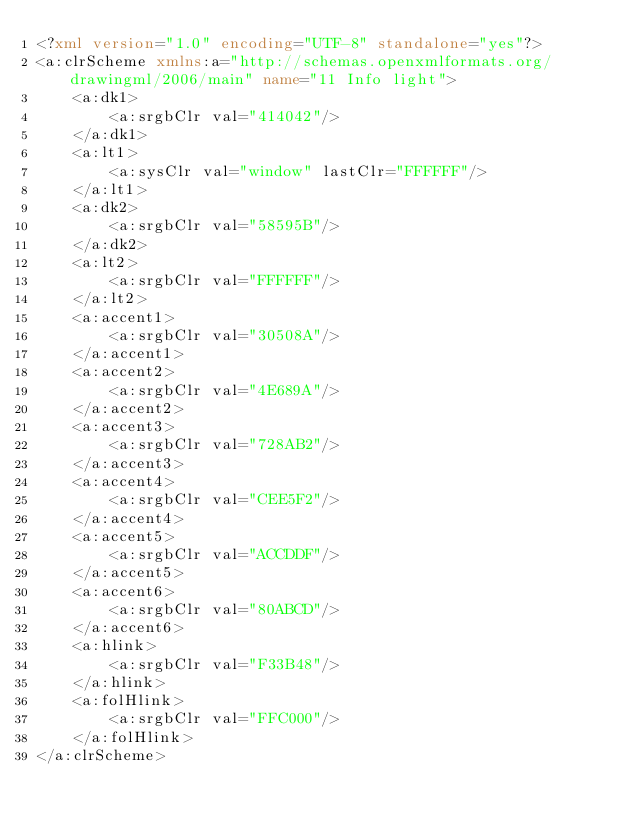<code> <loc_0><loc_0><loc_500><loc_500><_XML_><?xml version="1.0" encoding="UTF-8" standalone="yes"?>
<a:clrScheme xmlns:a="http://schemas.openxmlformats.org/drawingml/2006/main" name="11 Info light">
    <a:dk1>
        <a:srgbClr val="414042"/>
    </a:dk1>
    <a:lt1>
        <a:sysClr val="window" lastClr="FFFFFF"/>
    </a:lt1>
    <a:dk2>
        <a:srgbClr val="58595B"/>
    </a:dk2>
    <a:lt2>
        <a:srgbClr val="FFFFFF"/>
    </a:lt2>
    <a:accent1>
        <a:srgbClr val="30508A"/>
    </a:accent1>
    <a:accent2>
        <a:srgbClr val="4E689A"/>
    </a:accent2>
    <a:accent3>
        <a:srgbClr val="728AB2"/>
    </a:accent3>
    <a:accent4>
        <a:srgbClr val="CEE5F2"/>
    </a:accent4>
    <a:accent5>
        <a:srgbClr val="ACCDDF"/>
    </a:accent5>
    <a:accent6>
        <a:srgbClr val="80ABCD"/>
    </a:accent6>
    <a:hlink>
        <a:srgbClr val="F33B48"/>
    </a:hlink>
    <a:folHlink>
        <a:srgbClr val="FFC000"/>
    </a:folHlink>
</a:clrScheme></code> 